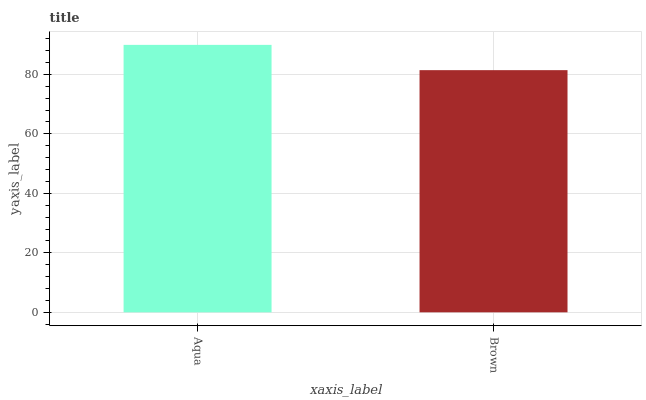Is Brown the minimum?
Answer yes or no. Yes. Is Aqua the maximum?
Answer yes or no. Yes. Is Brown the maximum?
Answer yes or no. No. Is Aqua greater than Brown?
Answer yes or no. Yes. Is Brown less than Aqua?
Answer yes or no. Yes. Is Brown greater than Aqua?
Answer yes or no. No. Is Aqua less than Brown?
Answer yes or no. No. Is Aqua the high median?
Answer yes or no. Yes. Is Brown the low median?
Answer yes or no. Yes. Is Brown the high median?
Answer yes or no. No. Is Aqua the low median?
Answer yes or no. No. 